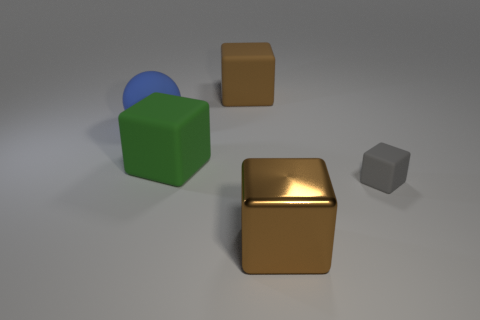Is there anything else that has the same shape as the big blue matte thing?
Provide a succinct answer. No. There is a big object on the right side of the cube behind the big green object; what shape is it?
Offer a terse response. Cube. Are there any other things that have the same size as the gray rubber block?
Your answer should be very brief. No. What shape is the large thing in front of the block that is right of the brown thing that is in front of the small block?
Provide a succinct answer. Cube. How many things are brown cubes that are in front of the small matte thing or matte objects right of the big brown matte object?
Offer a very short reply. 2. Does the shiny cube have the same size as the brown cube behind the large green block?
Your answer should be compact. Yes. Is the material of the big brown thing that is behind the big blue matte thing the same as the object on the left side of the green cube?
Your answer should be compact. Yes. Are there an equal number of blue matte objects that are on the left side of the large brown matte block and brown cubes that are to the left of the large metal cube?
Your answer should be compact. Yes. How many other big objects are the same color as the large shiny thing?
Your answer should be very brief. 1. How many matte things are either green objects or tiny blue objects?
Make the answer very short. 1. 